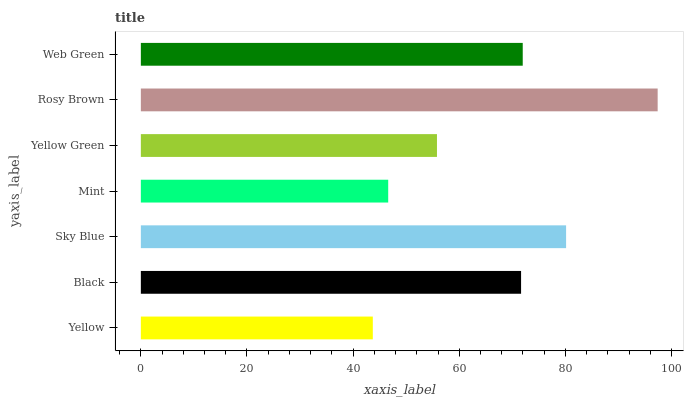Is Yellow the minimum?
Answer yes or no. Yes. Is Rosy Brown the maximum?
Answer yes or no. Yes. Is Black the minimum?
Answer yes or no. No. Is Black the maximum?
Answer yes or no. No. Is Black greater than Yellow?
Answer yes or no. Yes. Is Yellow less than Black?
Answer yes or no. Yes. Is Yellow greater than Black?
Answer yes or no. No. Is Black less than Yellow?
Answer yes or no. No. Is Black the high median?
Answer yes or no. Yes. Is Black the low median?
Answer yes or no. Yes. Is Sky Blue the high median?
Answer yes or no. No. Is Yellow the low median?
Answer yes or no. No. 